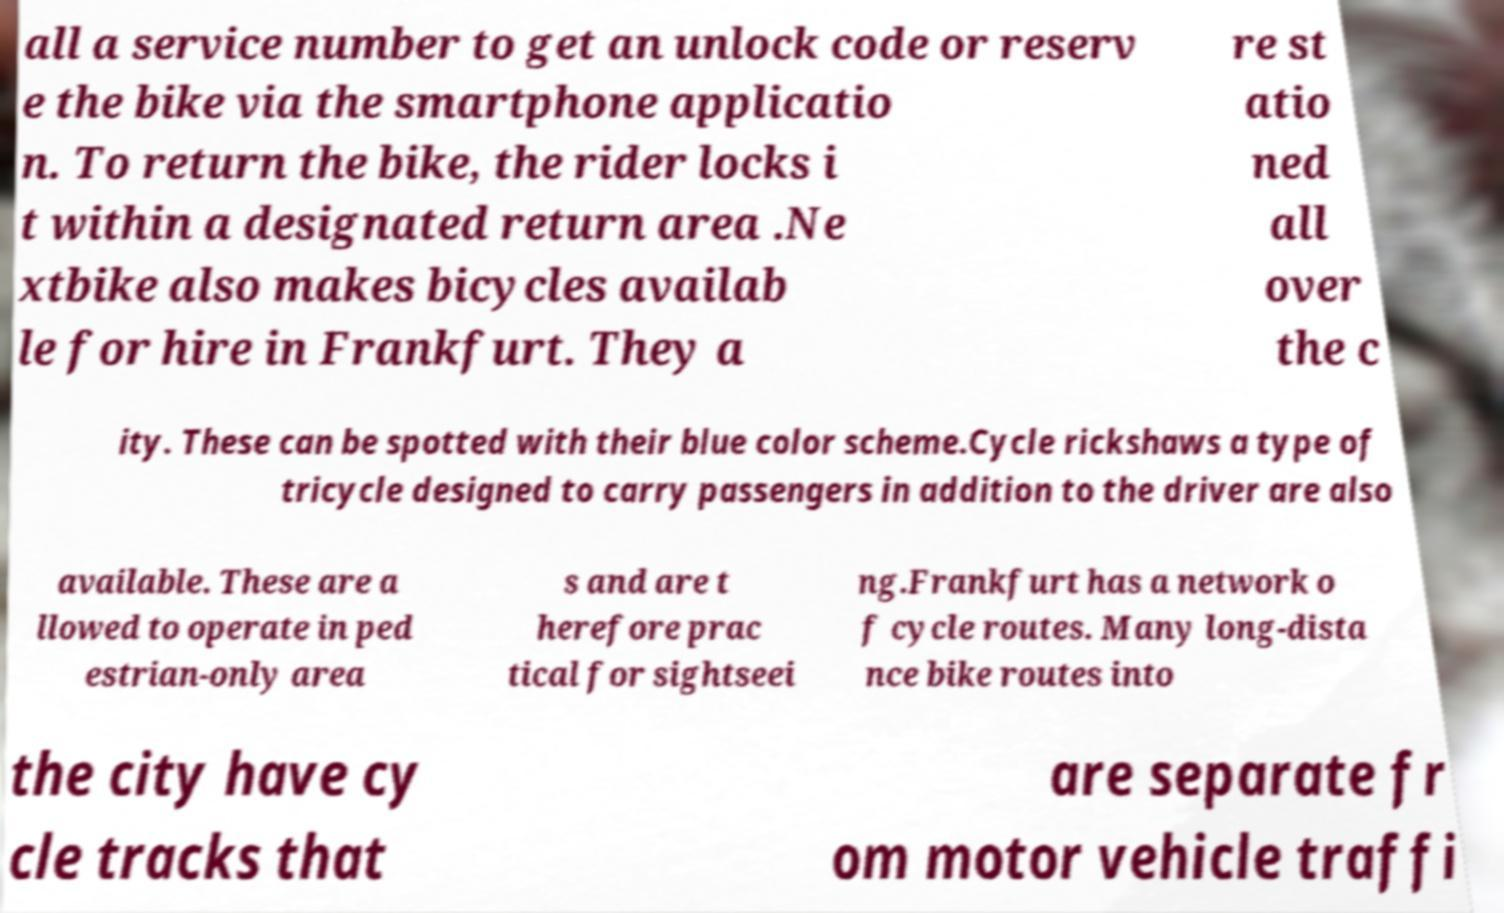Could you extract and type out the text from this image? all a service number to get an unlock code or reserv e the bike via the smartphone applicatio n. To return the bike, the rider locks i t within a designated return area .Ne xtbike also makes bicycles availab le for hire in Frankfurt. They a re st atio ned all over the c ity. These can be spotted with their blue color scheme.Cycle rickshaws a type of tricycle designed to carry passengers in addition to the driver are also available. These are a llowed to operate in ped estrian-only area s and are t herefore prac tical for sightseei ng.Frankfurt has a network o f cycle routes. Many long-dista nce bike routes into the city have cy cle tracks that are separate fr om motor vehicle traffi 